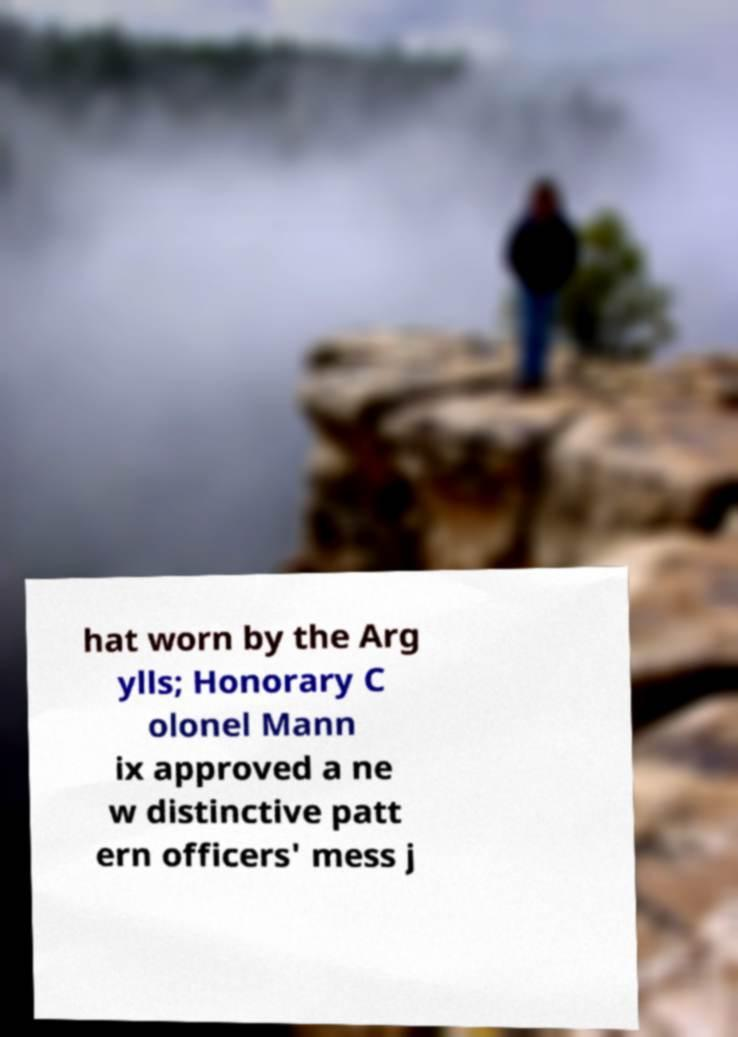Could you extract and type out the text from this image? hat worn by the Arg ylls; Honorary C olonel Mann ix approved a ne w distinctive patt ern officers' mess j 